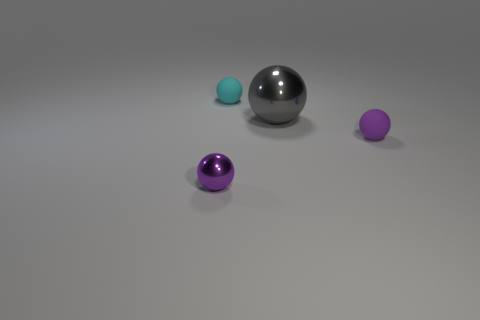Add 3 gray things. How many objects exist? 7 Add 2 balls. How many balls are left? 6 Add 4 tiny metal balls. How many tiny metal balls exist? 5 Subtract 0 gray blocks. How many objects are left? 4 Subtract all tiny shiny objects. Subtract all large yellow metal spheres. How many objects are left? 3 